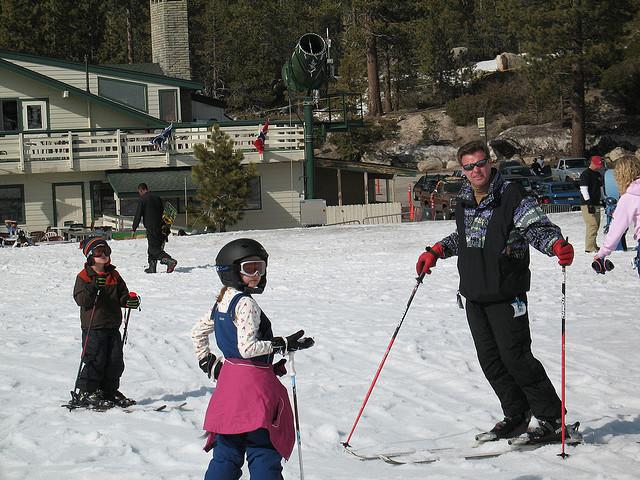Is the person with the pink coat around her waste an adult?
Give a very brief answer. No. How many people are wearing a pink hat?
Answer briefly. 0. What are the children learning?
Quick response, please. Skiing. How many people are in this photo?
Be succinct. 7. What is the man wearing on his face?
Be succinct. Sunglasses. How many girls are in this group?
Quick response, please. 2. 